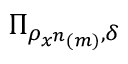<formula> <loc_0><loc_0><loc_500><loc_500>\Pi _ { \rho _ { x ^ { n } \left ( m \right ) } , \delta }</formula> 